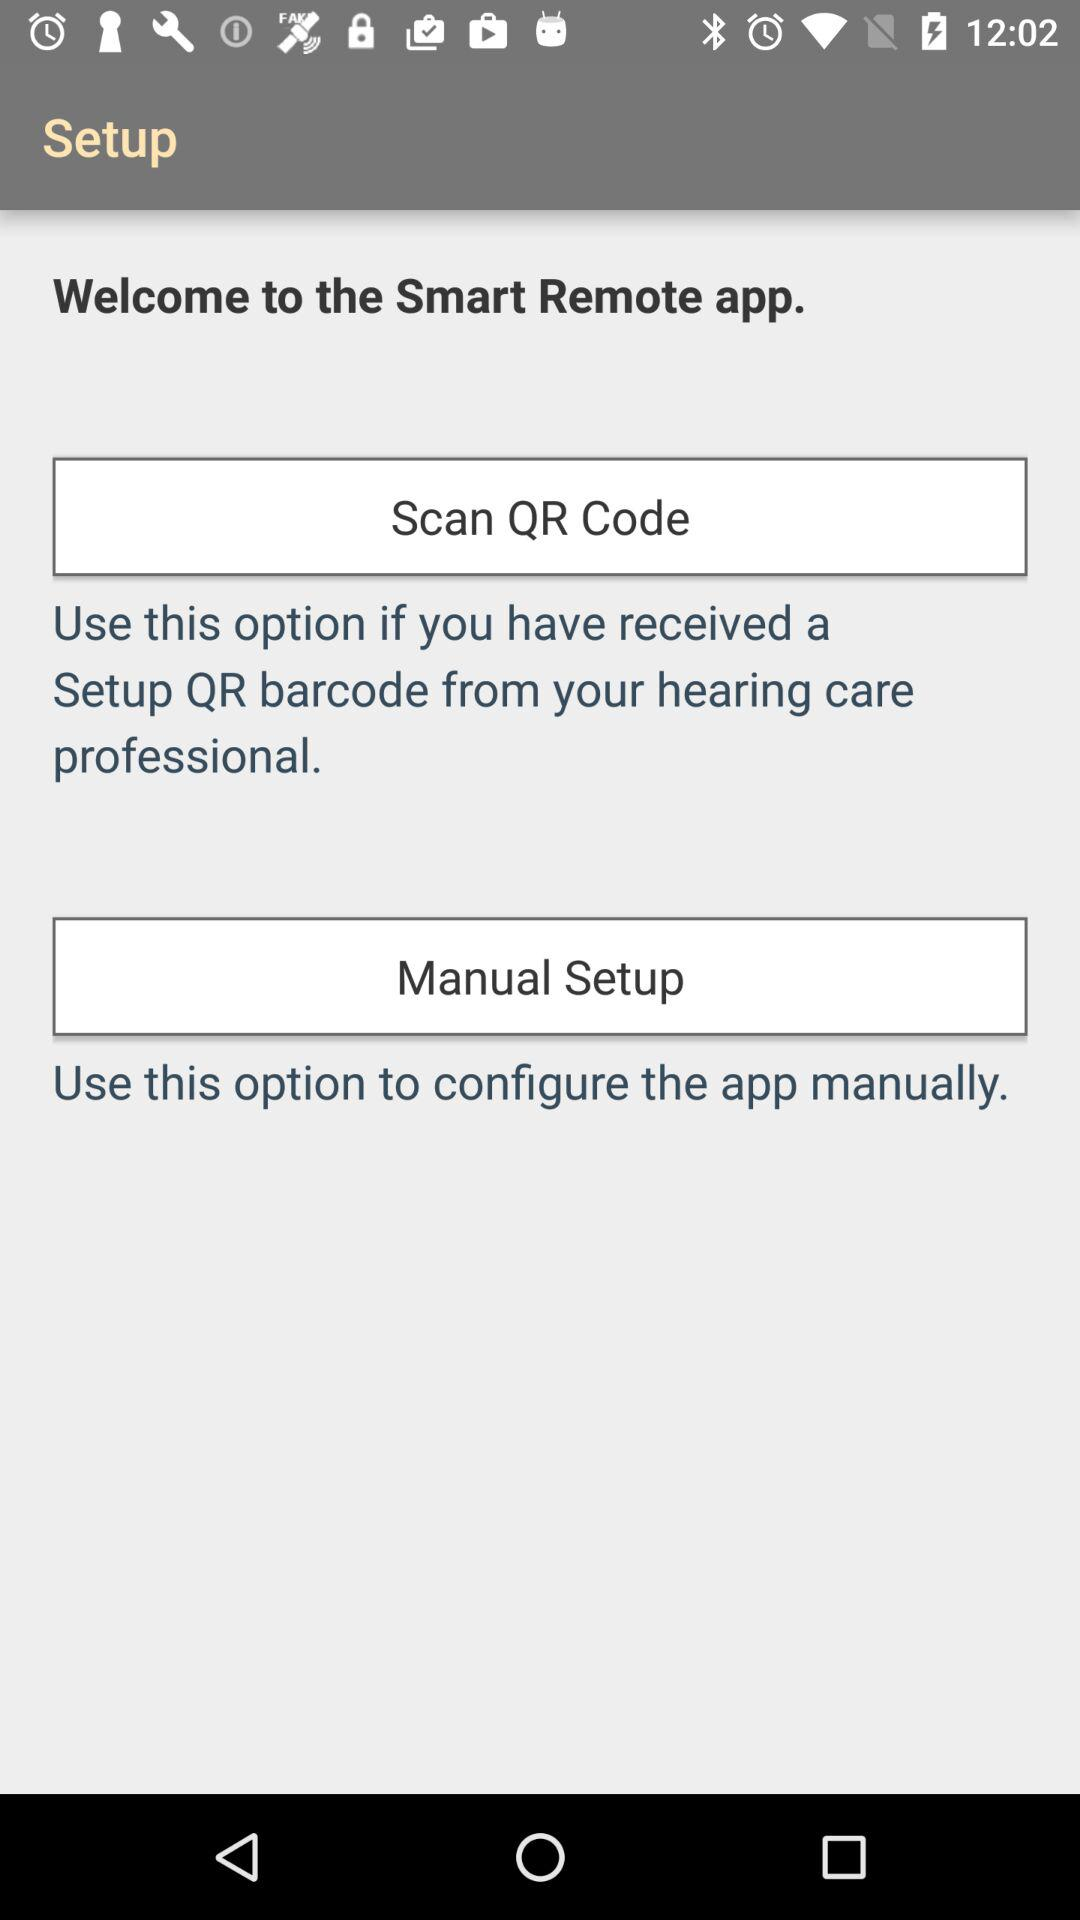When should the "Manual Setup" option be used? The "Manual Setup" option should be used to configure the app manually. 